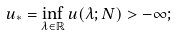<formula> <loc_0><loc_0><loc_500><loc_500>u _ { * } = \inf _ { \lambda \in \mathbb { R } } u ( \lambda ; N ) > - \infty ;</formula> 